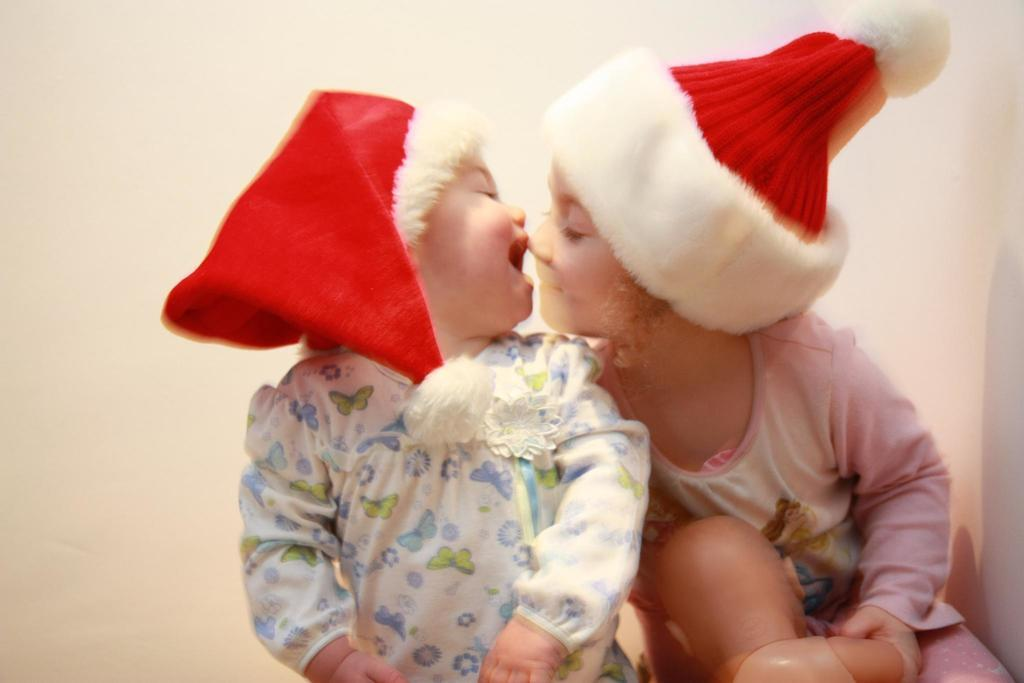How many children are present in the image? There are two kids in the image. What can be seen behind the kids in the image? There is a wall visible in the image. What type of bubble is being distributed by the kids in the image? There is no bubble or distribution of any kind present in the image. 